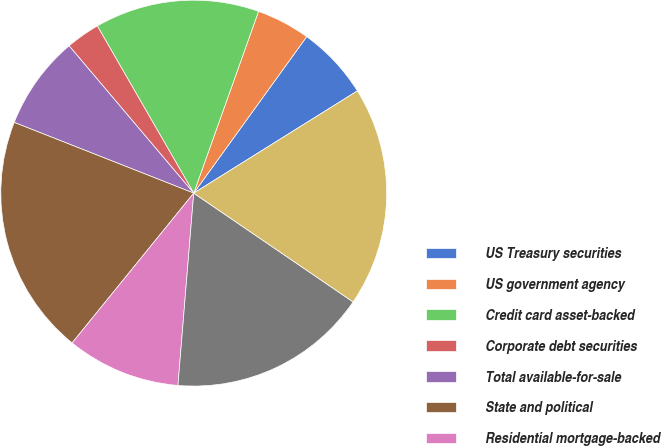<chart> <loc_0><loc_0><loc_500><loc_500><pie_chart><fcel>US Treasury securities<fcel>US government agency<fcel>Credit card asset-backed<fcel>Corporate debt securities<fcel>Total available-for-sale<fcel>State and political<fcel>Residential mortgage-backed<fcel>Other debt securities<fcel>Total held-to-maturity<nl><fcel>6.16%<fcel>4.5%<fcel>13.78%<fcel>2.85%<fcel>7.85%<fcel>20.12%<fcel>9.55%<fcel>16.77%<fcel>18.42%<nl></chart> 